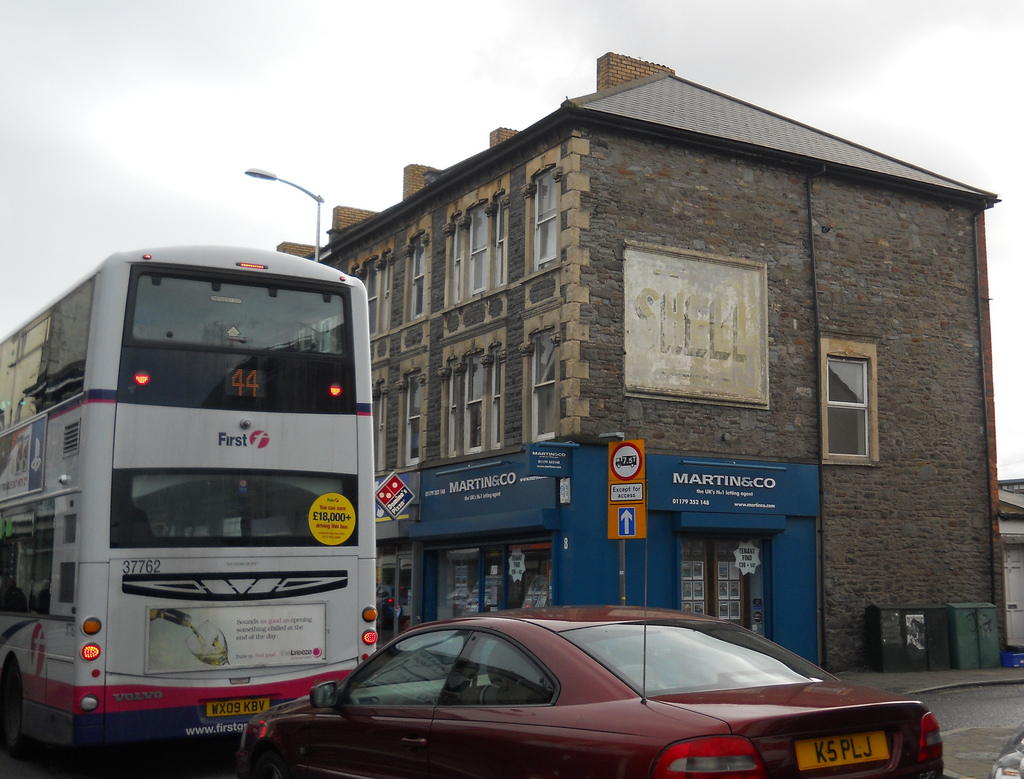Please provide a short description for this region: [0.8, 0.46, 0.85, 0.57]. The region marked by the coordinates [0.8, 0.46, 0.85, 0.57] corresponds to a window of a building, identifying this specific architectural feature. 